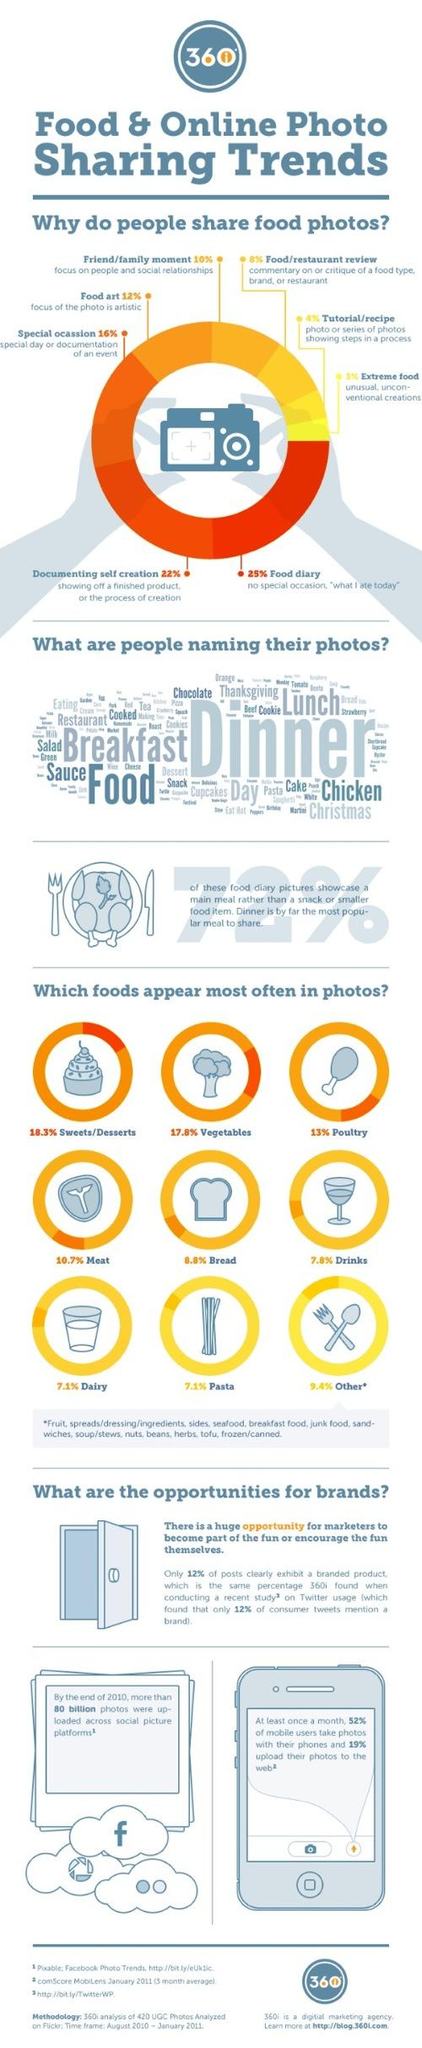Give some essential details in this illustration. Poultry is the third most commonly appearing food in photos, according to research. Seventy-two percent of food diary pictures show a main meal. The word cloud reveals that 'dinner' is the most commonly used term to describe food photos. The biggest reason for sharing food photos online is to maintain a food diary. 